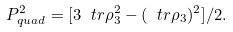Convert formula to latex. <formula><loc_0><loc_0><loc_500><loc_500>P _ { q u a d } ^ { 2 } = [ 3 \ t r \rho _ { 3 } ^ { 2 } - ( \ t r \rho _ { 3 } ) ^ { 2 } ] / 2 .</formula> 